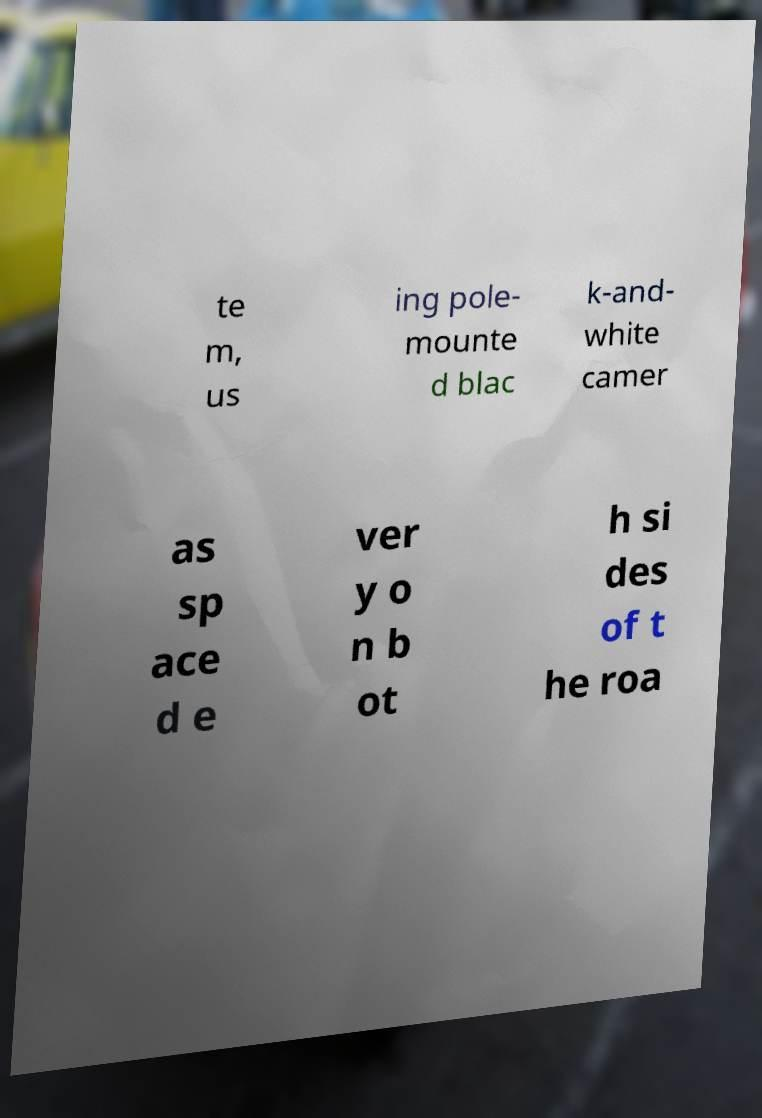Could you assist in decoding the text presented in this image and type it out clearly? te m, us ing pole- mounte d blac k-and- white camer as sp ace d e ver y o n b ot h si des of t he roa 